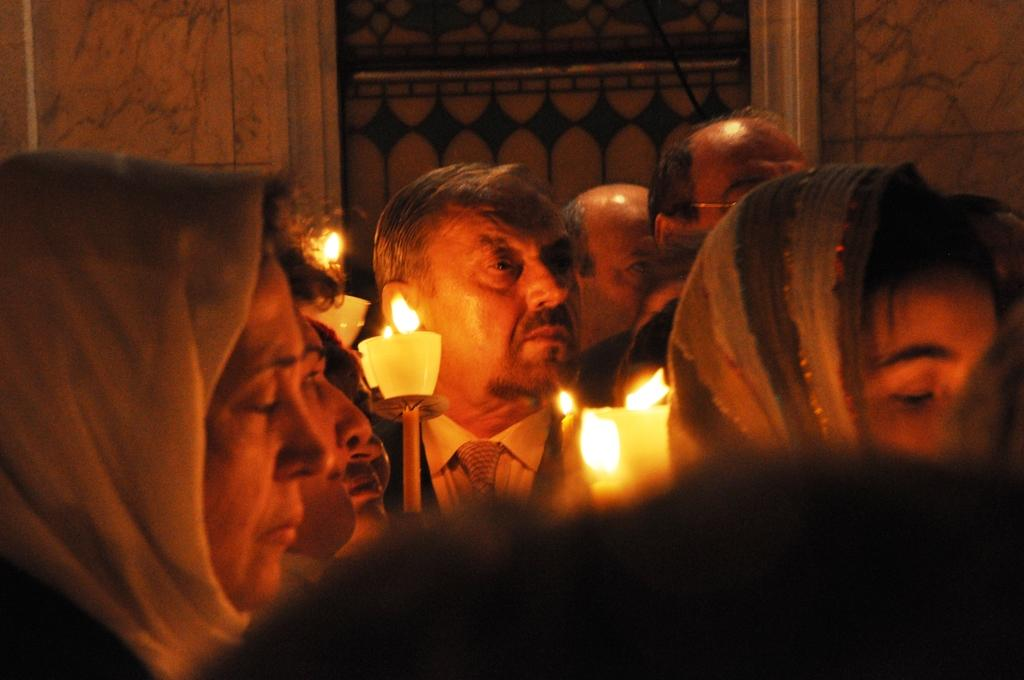How many people are in the image? There is a group of people in the image. What can be seen in the image besides the people? There are candles with flames in the image. What is visible in the background of the image? There is a wall in the background of the image. What type of apples are being used to extinguish the flames on the candles in the image? There are no apples present in the image, and they are not being used to extinguish the flames on the candles. 